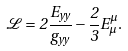<formula> <loc_0><loc_0><loc_500><loc_500>\mathcal { L } = 2 \frac { E _ { y y } } { g _ { y y } } - \frac { 2 } { 3 } E ^ { \mu } _ { \mu } .</formula> 